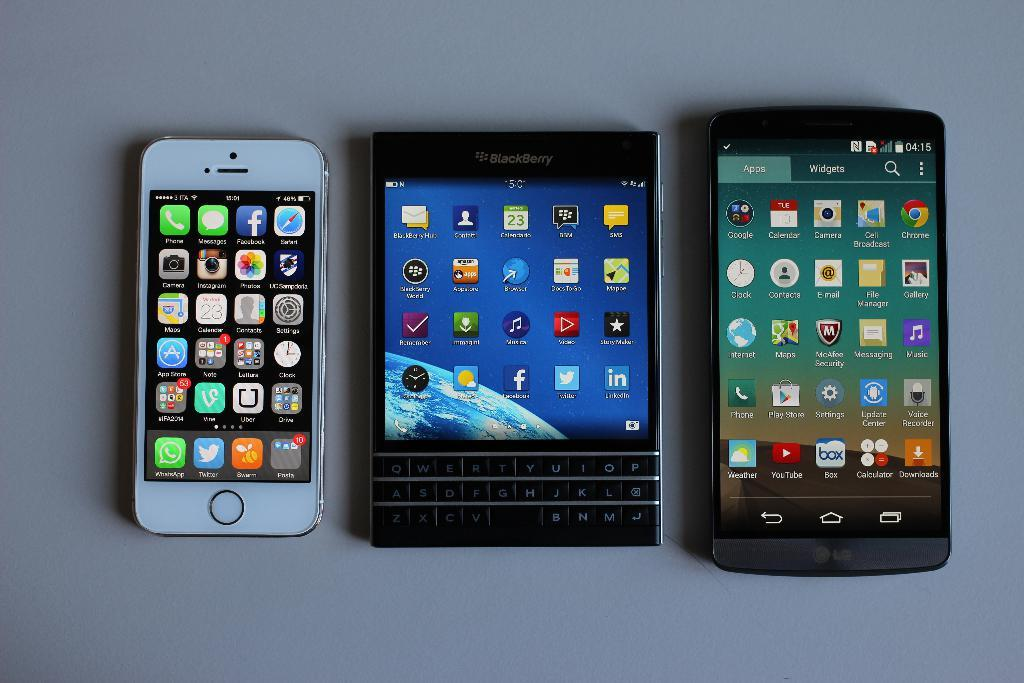<image>
Present a compact description of the photo's key features. Three different brands of cell phones sit in a row including a Blackberry. 